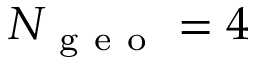Convert formula to latex. <formula><loc_0><loc_0><loc_500><loc_500>N _ { g e o } = 4</formula> 